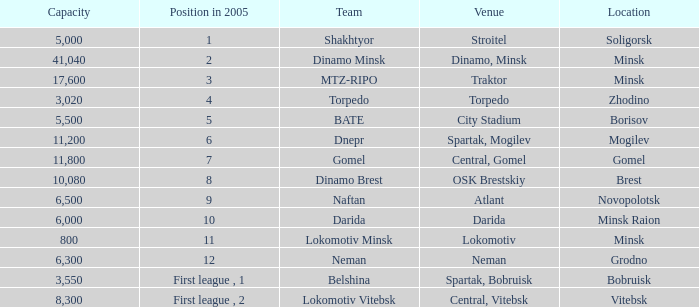Can you tell me the Venue that has the Position in 2005 of 8? OSK Brestskiy. 